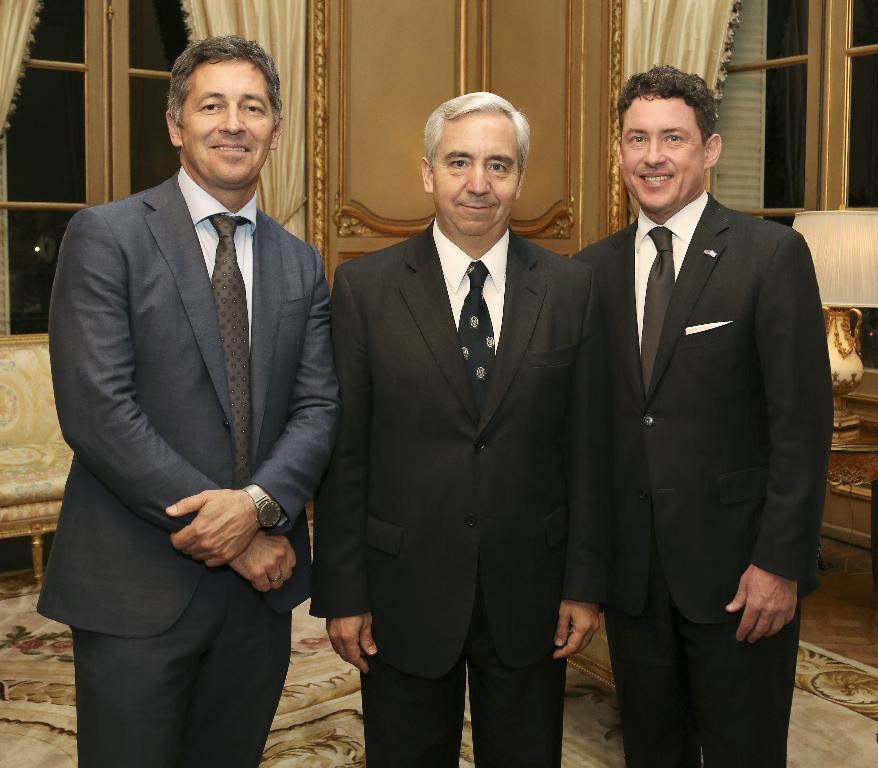Describe this image in one or two sentences. In this picture we can see three men standing holding a smile to the camera. They are wearing blazers and ties. On the background of the picture we can see a door windows and curtains. This is a floor carpet. This is a sofa. Here we can see a lamp. 